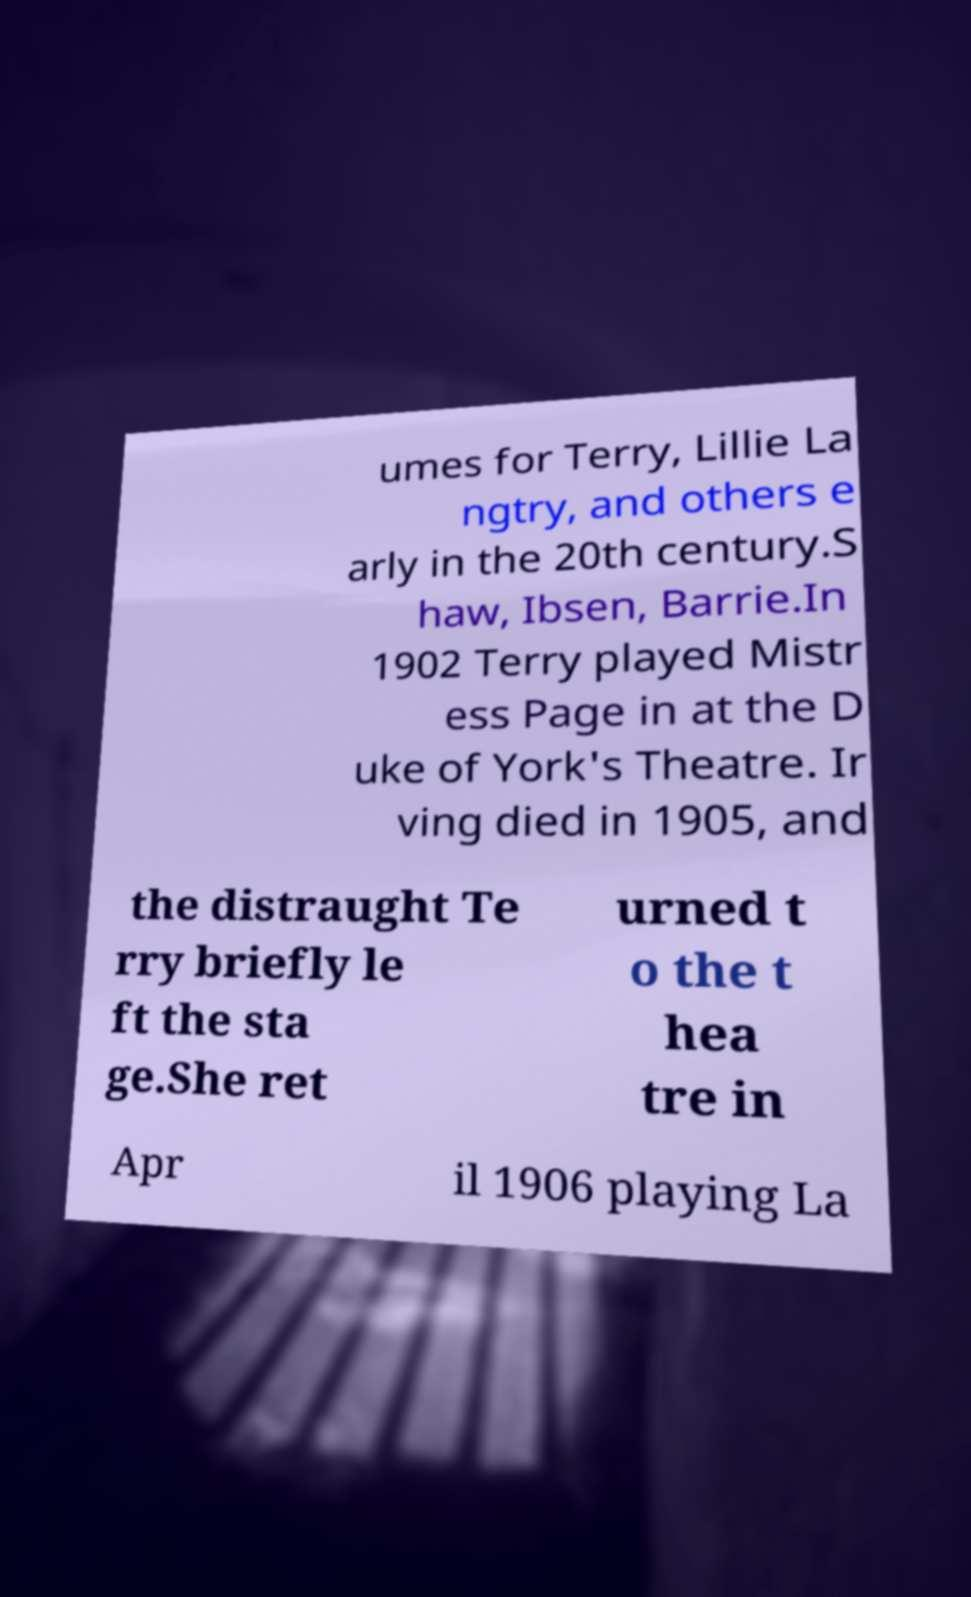Could you assist in decoding the text presented in this image and type it out clearly? umes for Terry, Lillie La ngtry, and others e arly in the 20th century.S haw, Ibsen, Barrie.In 1902 Terry played Mistr ess Page in at the D uke of York's Theatre. Ir ving died in 1905, and the distraught Te rry briefly le ft the sta ge.She ret urned t o the t hea tre in Apr il 1906 playing La 